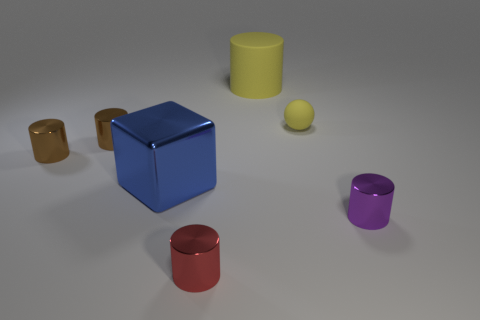Subtract all red cylinders. How many cylinders are left? 4 Subtract all red metal cylinders. How many cylinders are left? 4 Subtract all blue cylinders. Subtract all blue balls. How many cylinders are left? 5 Add 3 small brown metallic objects. How many objects exist? 10 Subtract all blocks. How many objects are left? 6 Subtract all large brown metallic cubes. Subtract all big matte cylinders. How many objects are left? 6 Add 1 large metallic things. How many large metallic things are left? 2 Add 6 small blue matte objects. How many small blue matte objects exist? 6 Subtract 0 cyan balls. How many objects are left? 7 